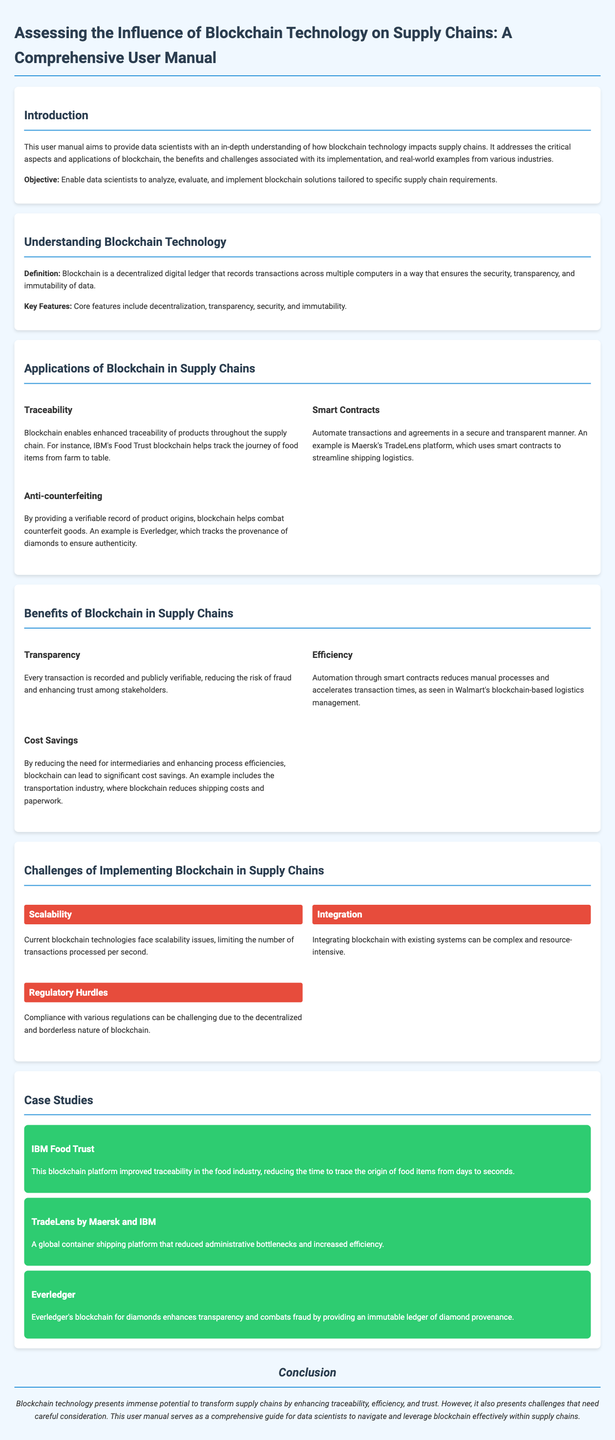what is the objective of the user manual? The user manual aims to provide data scientists with an understanding of how blockchain technology impacts supply chains.
Answer: Enable data scientists to analyze, evaluate, and implement blockchain solutions tailored to specific supply chain requirements what does blockchain ensure in terms of data? Blockchain is designed to ensure security, transparency, and immutability of data records.
Answer: Security, transparency, and immutability name one application of blockchain in supply chains. The document lists several applications; one example is traceability in supply chains.
Answer: Traceability which benefits of blockchain enhance trust among stakeholders? Transparency allows every transaction to be verifiable, thus enhancing trust.
Answer: Transparency what is a highlighted challenge in implementing blockchain? The document emphasizes multiple challenges; one is the scalability of current blockchain technologies.
Answer: Scalability how does IBM's Food Trust improve traceability? It reduces the time to trace the origin of food items dramatically.
Answer: From days to seconds which company uses smart contracts to streamline logistics? The document mentions Maersk's TradeLens platform as an example of this application.
Answer: Maersk name a regulatory challenge associated with blockchain. The document states that compliance with various regulations presents challenges.
Answer: Regulatory hurdles what is the conclusion regarding blockchain technology? The conclusion summarizes the potential and challenges of blockchain in supply chains.
Answer: Immense potential to transform supply chains 